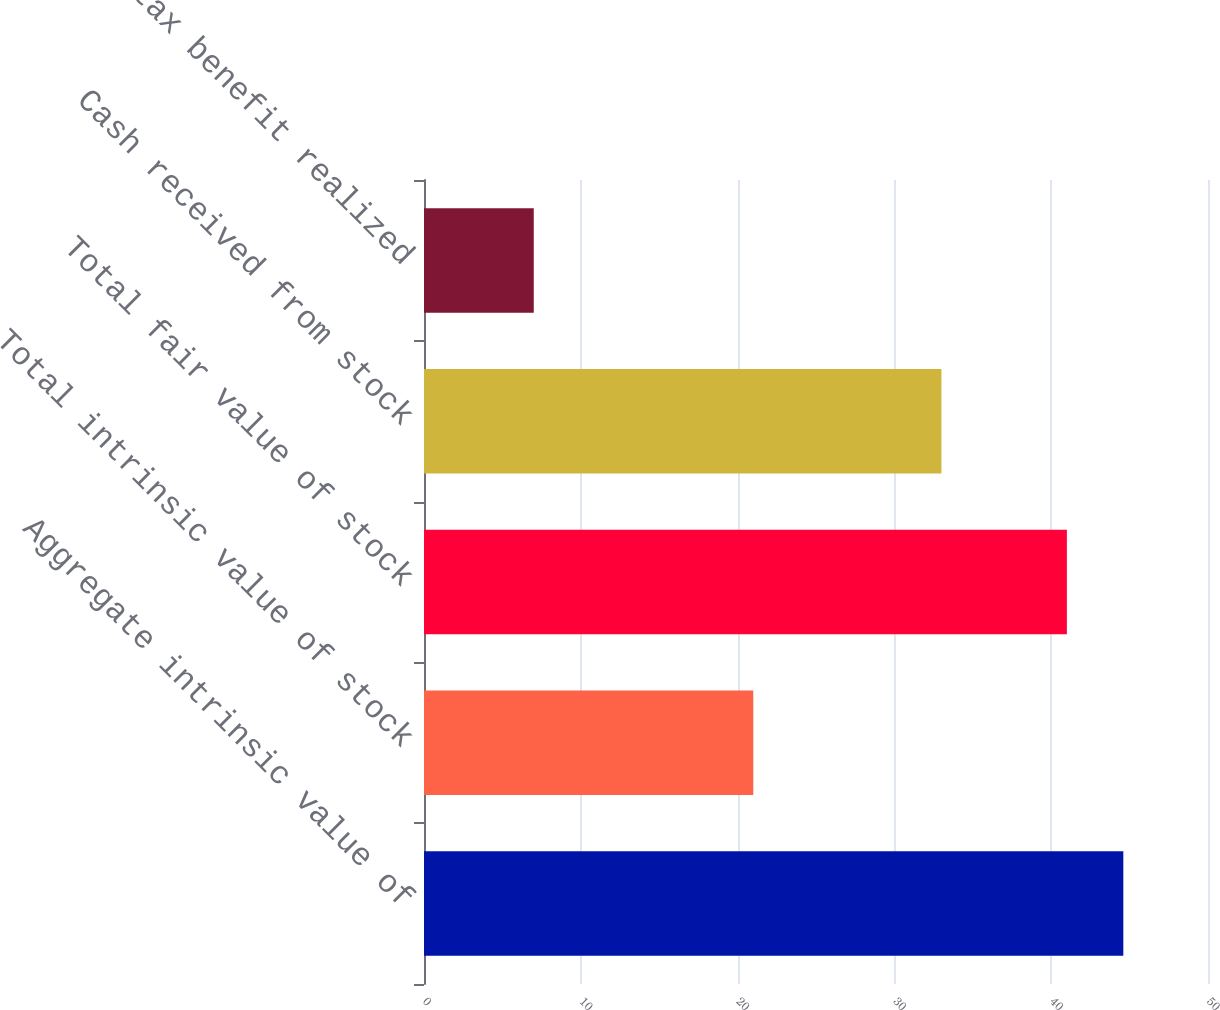Convert chart. <chart><loc_0><loc_0><loc_500><loc_500><bar_chart><fcel>Aggregate intrinsic value of<fcel>Total intrinsic value of stock<fcel>Total fair value of stock<fcel>Cash received from stock<fcel>Actual tax benefit realized<nl><fcel>44.6<fcel>21<fcel>41<fcel>33<fcel>7<nl></chart> 